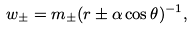Convert formula to latex. <formula><loc_0><loc_0><loc_500><loc_500>w _ { \pm } = m _ { \pm } ( r \pm \alpha \cos \theta ) ^ { - 1 } ,</formula> 